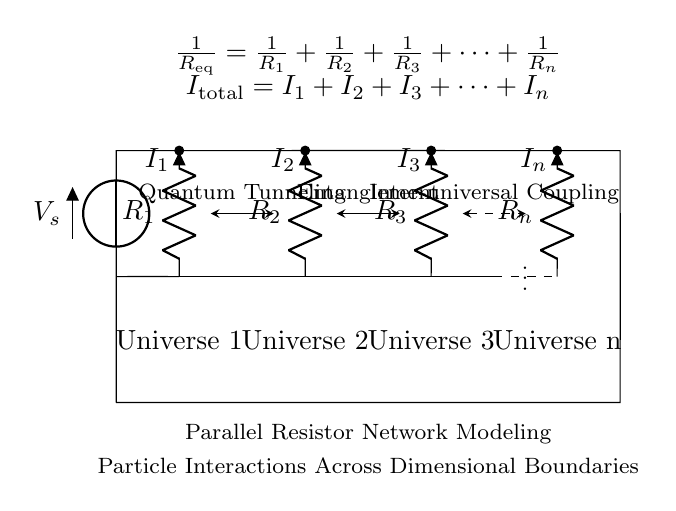What is the voltage source in this circuit? The voltage source is represented by the symbol V_s, located on the left side of the circuit diagram, indicating the source of potential difference.
Answer: V_s How many resistors are in parallel? The diagram explicitly shows four resistors labeled R_1, R_2, R_3, and R_n, indicating that there are four resistors connected in parallel.
Answer: 4 What does the total current in the circuit equal? According to the expression provided in the diagram, the total current I_total is the sum of the individual currents through each of the resistors: I_total = I_1 + I_2 + I_3 + ... + I_n. Therefore, the answer reflects the relationship among the currents.
Answer: I_1 + I_2 + I_3 + ... + I_n What is the equivalent resistance for this parallel network? The equivalent resistance R_eq is calculated using the formula given in the diagram, which states that the reciprocal of the equivalent resistance is the sum of the reciprocals of each individual resistance: 1/R_eq = 1/R_1 + 1/R_2 + 1/R_3 + ... + 1/R_n. This encompasses all resistors in the circuit.
Answer: 1/R_1 + 1/R_2 + 1/R_3 + ... + 1/R_n Which concepts are illustrated between Universe 1 and Universe 2? The graphical representation between Universe 1 and Universe 2 includes an arrow labeled 'Quantum Tunneling,' denoting the connection of quantum behaviors between these two universes in the context of particle interactions.
Answer: Quantum Tunneling What type of coupling is illustrated between Universe 3 and Universe n? The dashed line between Universe 3 and Universe n indicates 'Inter-universal Coupling,' which reflects the notion of interactions that can occur across different dimensions or universes in the theoretical framework of quantum mechanics.
Answer: Inter-universal Coupling 